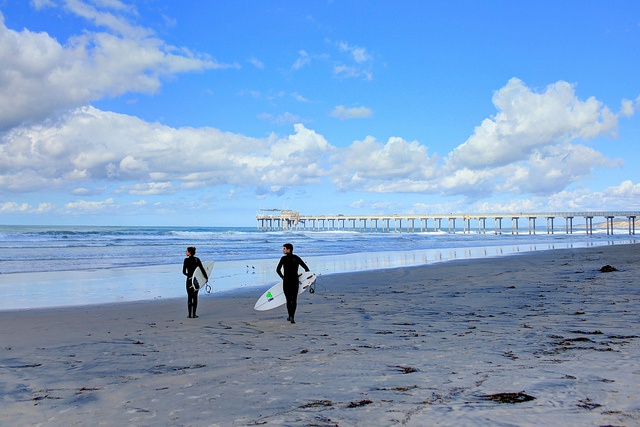Describe the objects in this image and their specific colors. I can see people in gray, black, and darkgray tones, people in gray, black, darkgray, and lightblue tones, surfboard in gray, lightblue, darkgray, and lightgray tones, and surfboard in gray, darkgray, black, and lightblue tones in this image. 